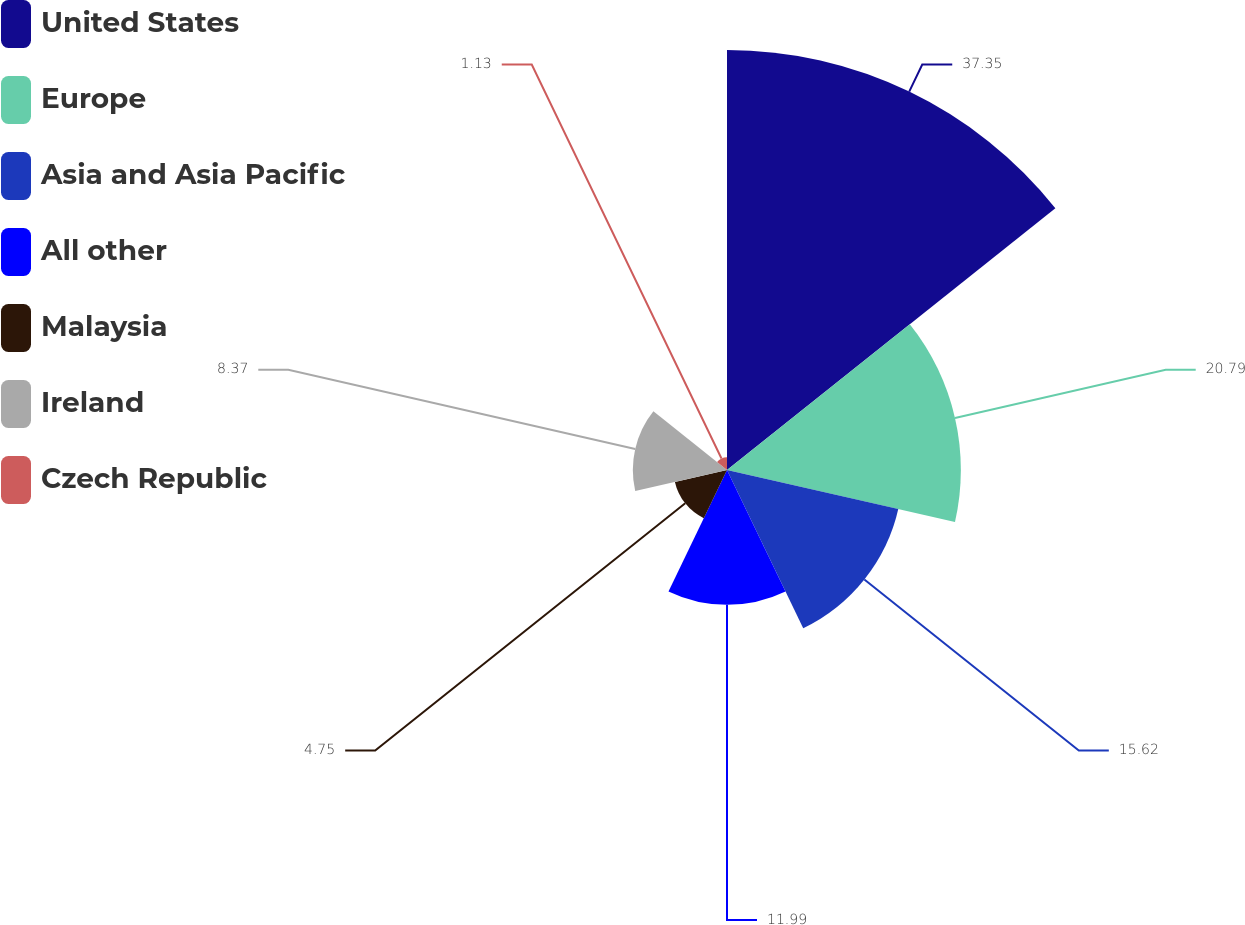<chart> <loc_0><loc_0><loc_500><loc_500><pie_chart><fcel>United States<fcel>Europe<fcel>Asia and Asia Pacific<fcel>All other<fcel>Malaysia<fcel>Ireland<fcel>Czech Republic<nl><fcel>37.34%<fcel>20.79%<fcel>15.62%<fcel>11.99%<fcel>4.75%<fcel>8.37%<fcel>1.13%<nl></chart> 